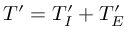<formula> <loc_0><loc_0><loc_500><loc_500>{ T } ^ { \prime } = { T } _ { I } ^ { \prime } + { T } _ { E } ^ { \prime }</formula> 